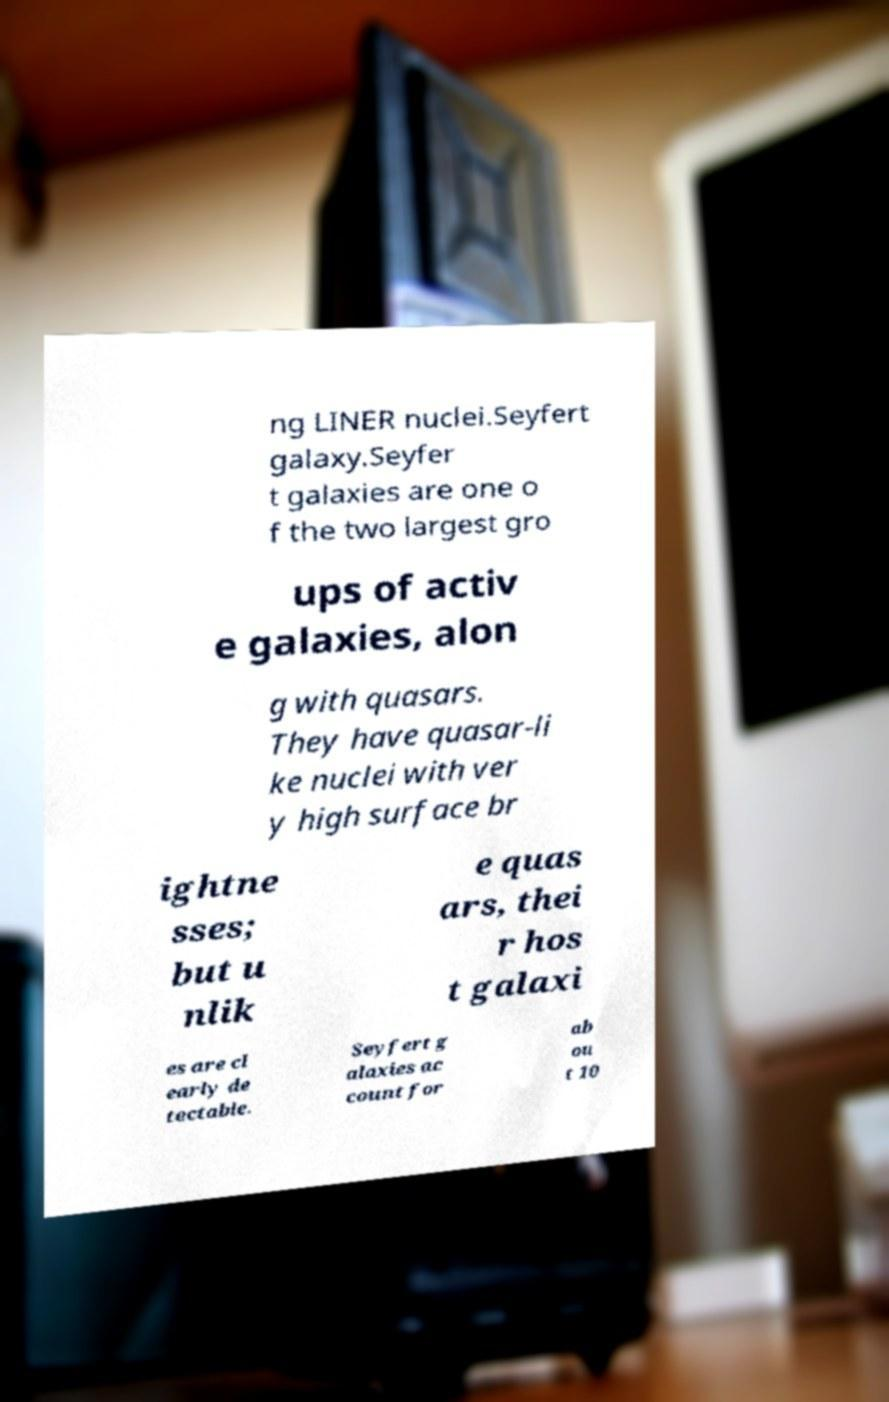Could you assist in decoding the text presented in this image and type it out clearly? ng LINER nuclei.Seyfert galaxy.Seyfer t galaxies are one o f the two largest gro ups of activ e galaxies, alon g with quasars. They have quasar-li ke nuclei with ver y high surface br ightne sses; but u nlik e quas ars, thei r hos t galaxi es are cl early de tectable. Seyfert g alaxies ac count for ab ou t 10 